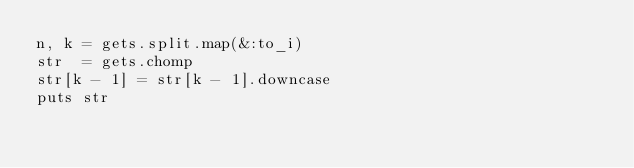<code> <loc_0><loc_0><loc_500><loc_500><_Ruby_>n, k = gets.split.map(&:to_i)
str  = gets.chomp
str[k - 1] = str[k - 1].downcase
puts str</code> 